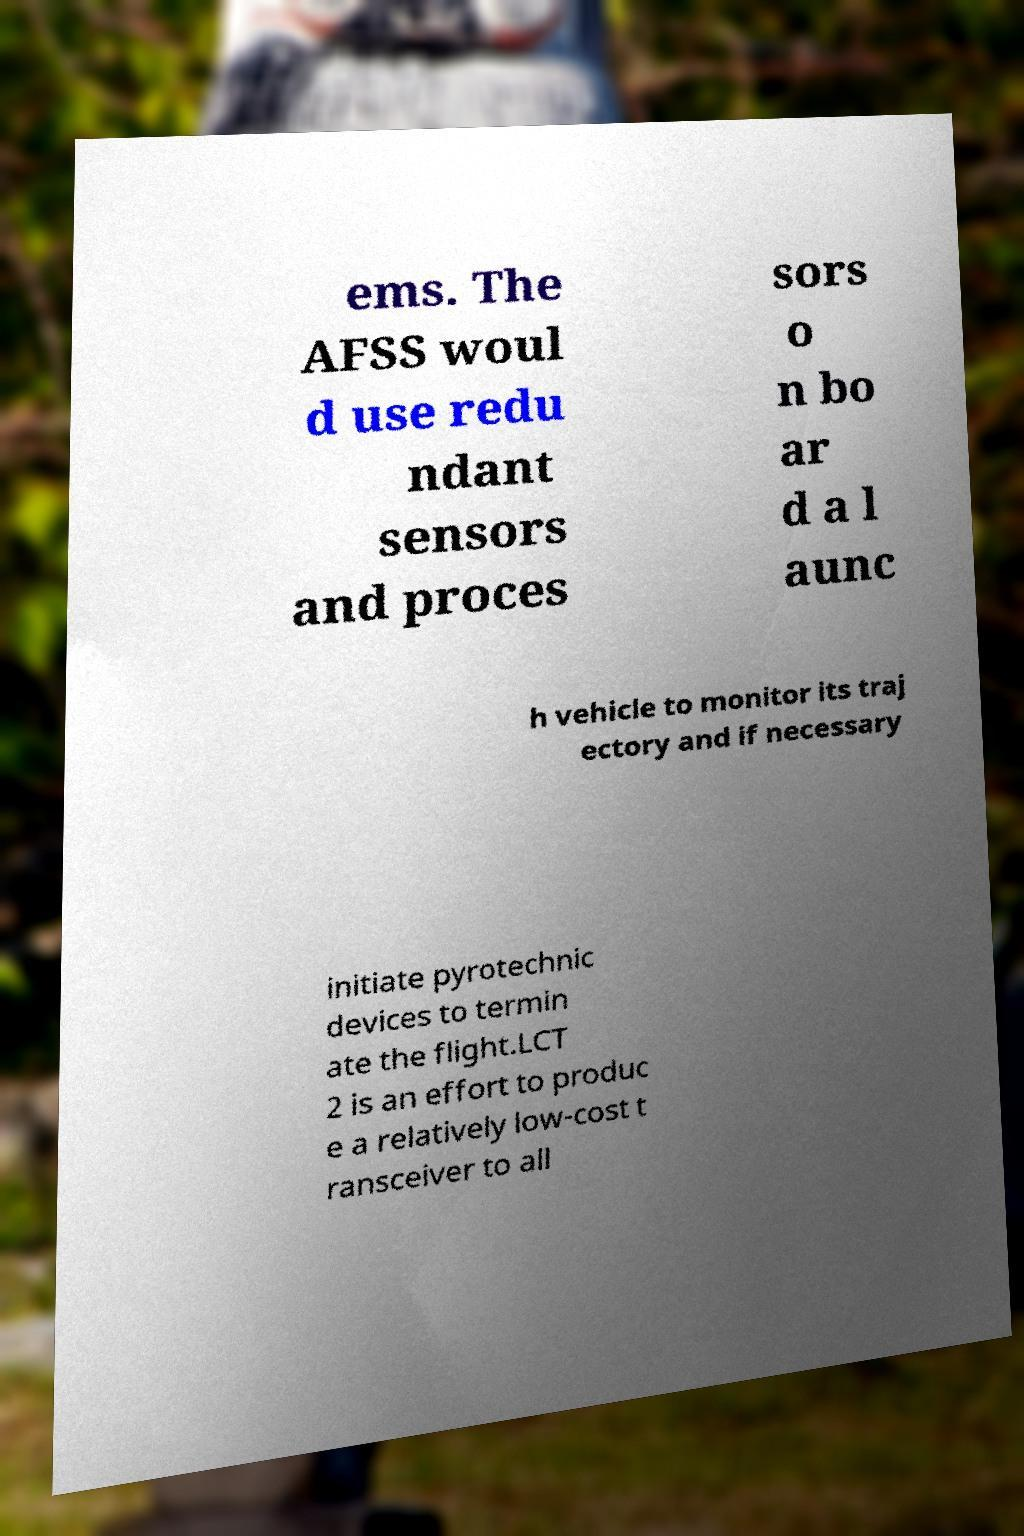Could you extract and type out the text from this image? ems. The AFSS woul d use redu ndant sensors and proces sors o n bo ar d a l aunc h vehicle to monitor its traj ectory and if necessary initiate pyrotechnic devices to termin ate the flight.LCT 2 is an effort to produc e a relatively low-cost t ransceiver to all 